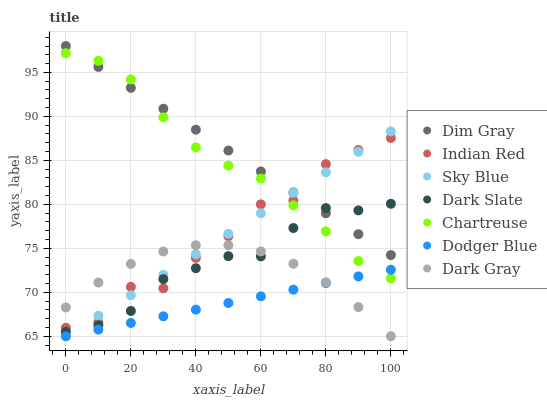Does Dodger Blue have the minimum area under the curve?
Answer yes or no. Yes. Does Dim Gray have the maximum area under the curve?
Answer yes or no. Yes. Does Dark Gray have the minimum area under the curve?
Answer yes or no. No. Does Dark Gray have the maximum area under the curve?
Answer yes or no. No. Is Dim Gray the smoothest?
Answer yes or no. Yes. Is Indian Red the roughest?
Answer yes or no. Yes. Is Dark Gray the smoothest?
Answer yes or no. No. Is Dark Gray the roughest?
Answer yes or no. No. Does Dark Gray have the lowest value?
Answer yes or no. Yes. Does Dark Slate have the lowest value?
Answer yes or no. No. Does Dim Gray have the highest value?
Answer yes or no. Yes. Does Dark Gray have the highest value?
Answer yes or no. No. Is Dark Gray less than Dim Gray?
Answer yes or no. Yes. Is Chartreuse greater than Dark Gray?
Answer yes or no. Yes. Does Dark Slate intersect Dark Gray?
Answer yes or no. Yes. Is Dark Slate less than Dark Gray?
Answer yes or no. No. Is Dark Slate greater than Dark Gray?
Answer yes or no. No. Does Dark Gray intersect Dim Gray?
Answer yes or no. No. 